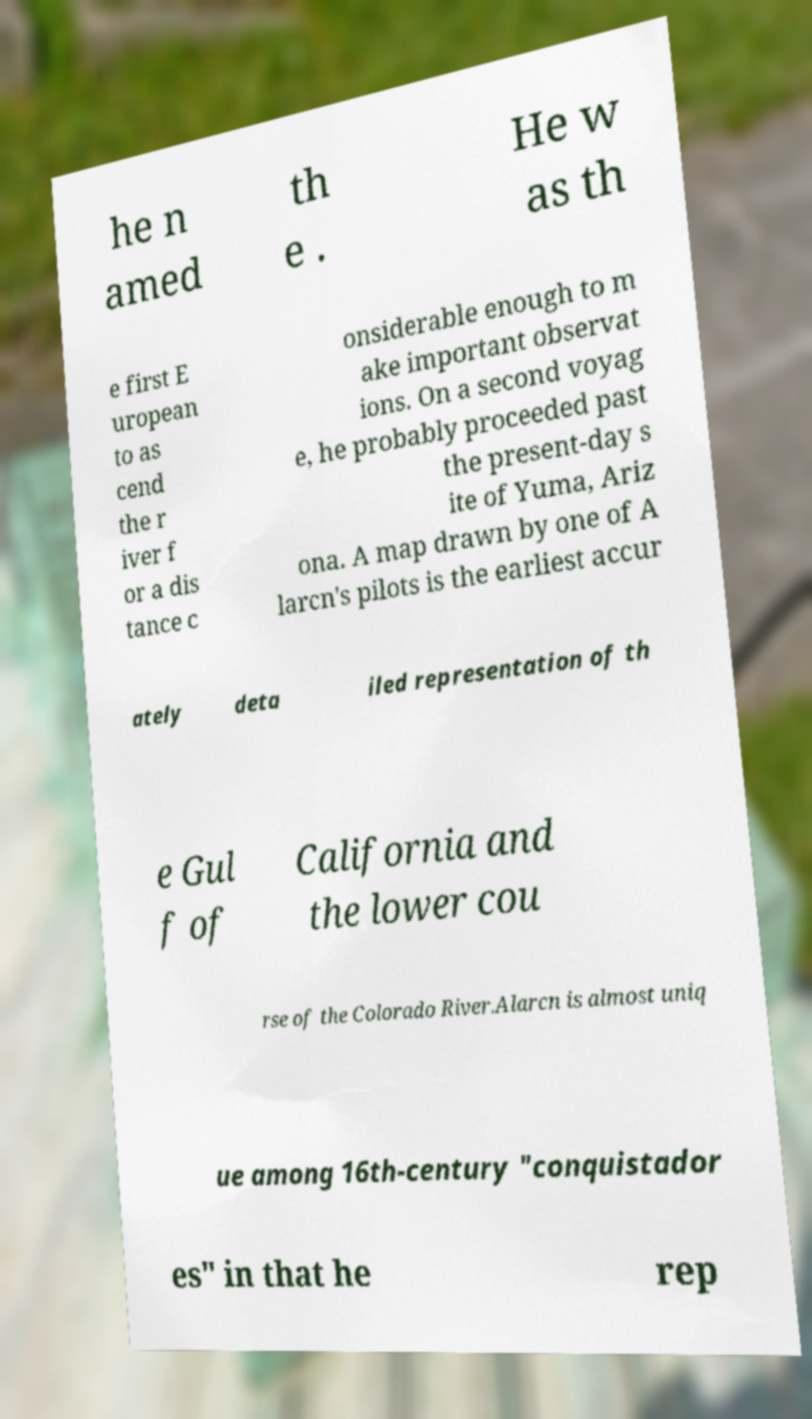There's text embedded in this image that I need extracted. Can you transcribe it verbatim? he n amed th e . He w as th e first E uropean to as cend the r iver f or a dis tance c onsiderable enough to m ake important observat ions. On a second voyag e, he probably proceeded past the present-day s ite of Yuma, Ariz ona. A map drawn by one of A larcn's pilots is the earliest accur ately deta iled representation of th e Gul f of California and the lower cou rse of the Colorado River.Alarcn is almost uniq ue among 16th-century "conquistador es" in that he rep 